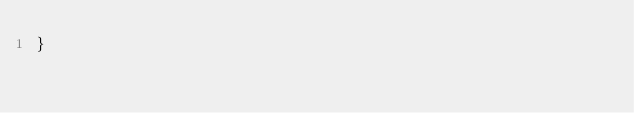Convert code to text. <code><loc_0><loc_0><loc_500><loc_500><_CSS_>}
</code> 